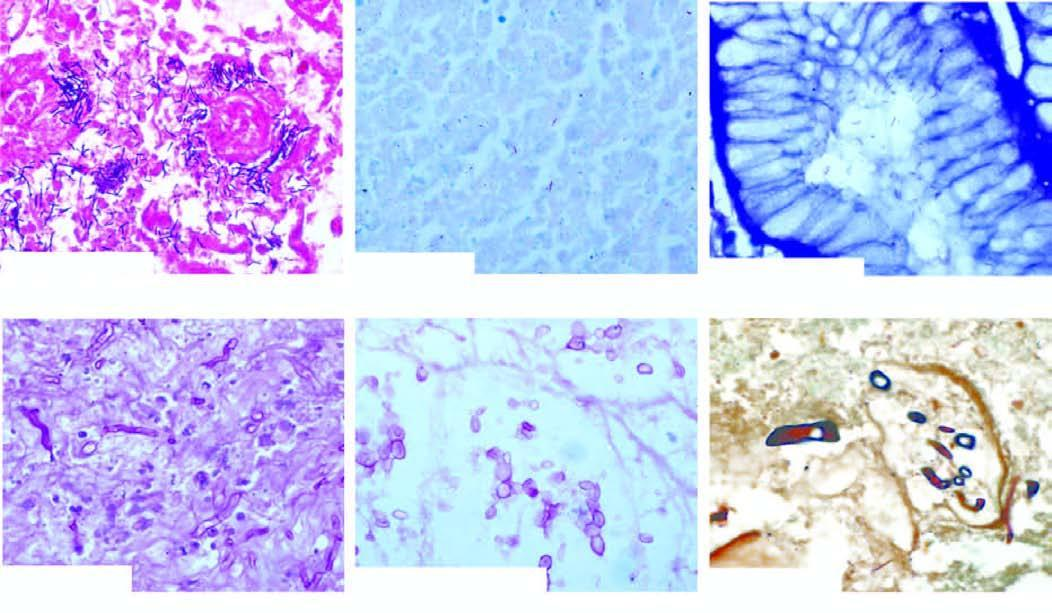s ommon stains used for demonstration of microbes?
Answer the question using a single word or phrase. Yes 